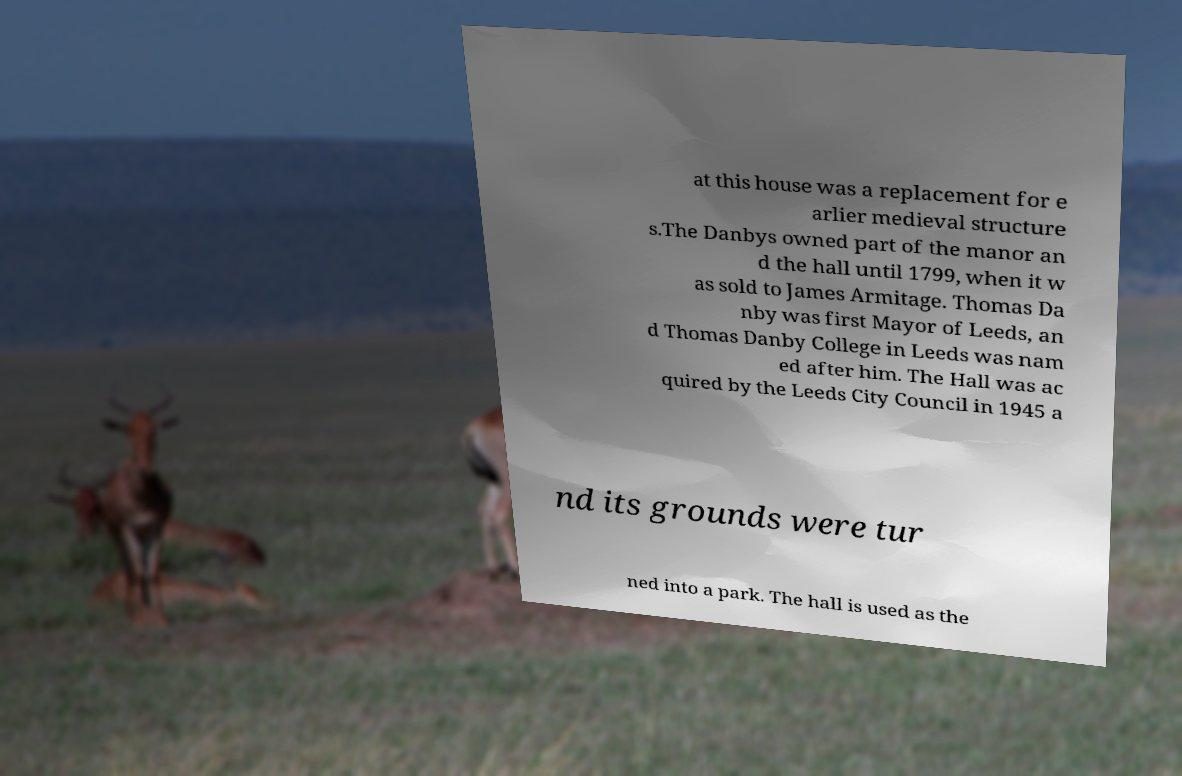Can you accurately transcribe the text from the provided image for me? at this house was a replacement for e arlier medieval structure s.The Danbys owned part of the manor an d the hall until 1799, when it w as sold to James Armitage. Thomas Da nby was first Mayor of Leeds, an d Thomas Danby College in Leeds was nam ed after him. The Hall was ac quired by the Leeds City Council in 1945 a nd its grounds were tur ned into a park. The hall is used as the 